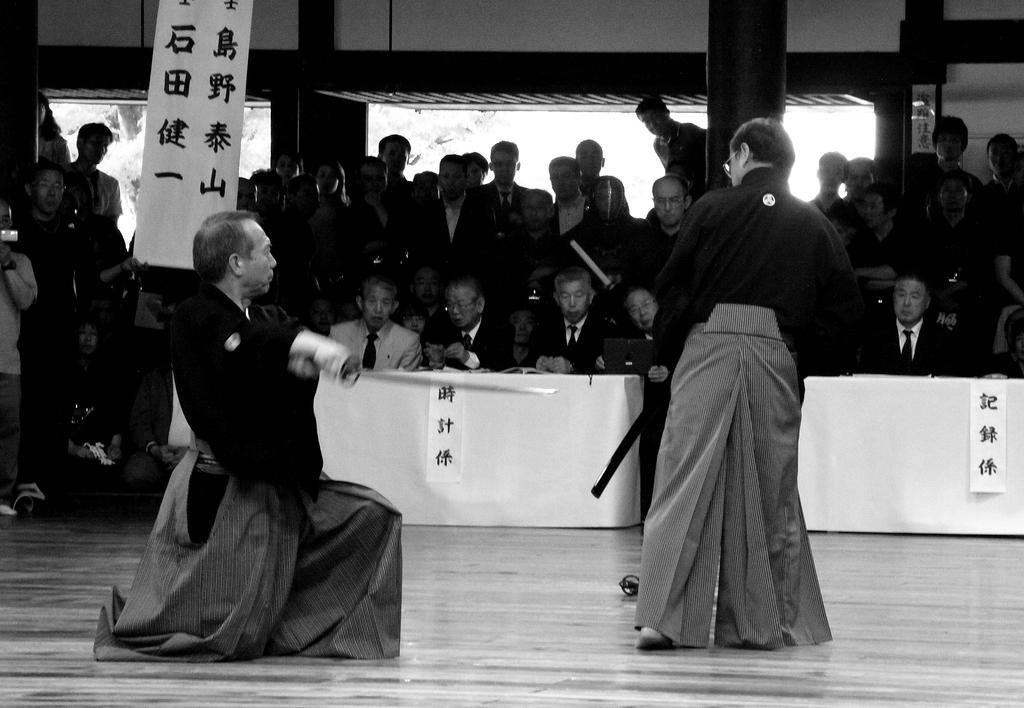Could you give a brief overview of what you see in this image? This image is taken indoors. At the bottom of the image there is a floor. In the background many people are standing on the floor and a few people are sitting on the chairs and there is a table with a table cloth and a few things on it. In the middle of the image there are two men and there is a banner with a text on it. At the top of the image there is a wall with pillars. 